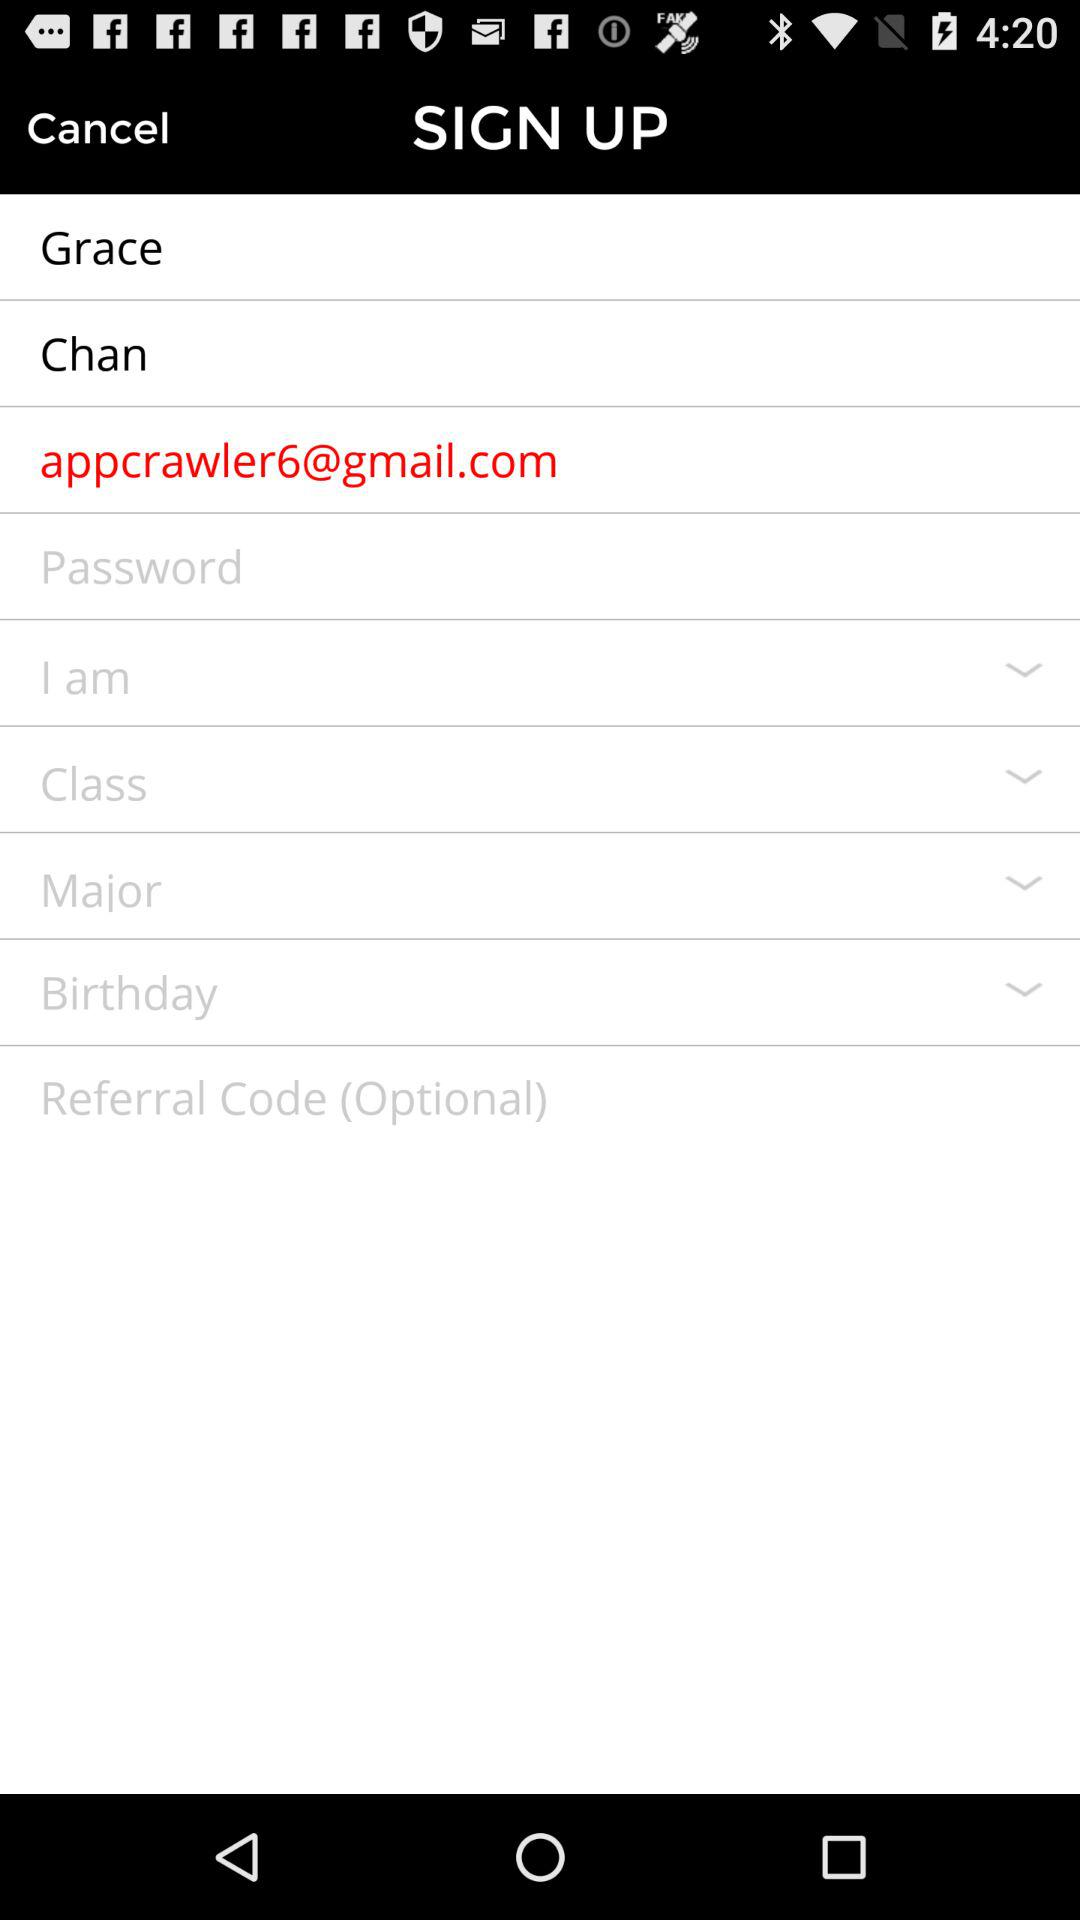What is the email address? The email address is appcrawler6@gmail.com. 